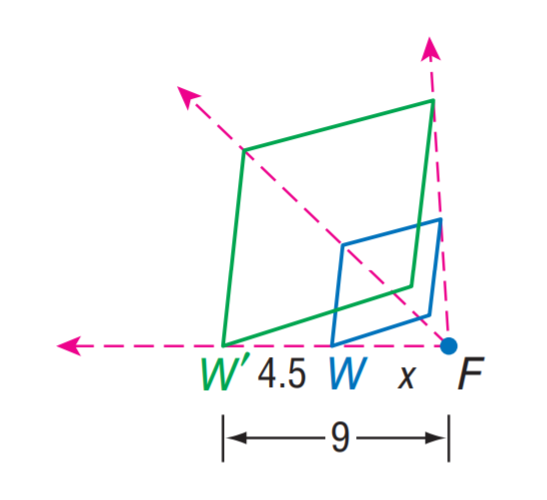Can you explain why the other options are incorrect for the scale factor from W to W'? Certainly! The scale factor is a proportional value that defines how much larger or smaller one object is compared to another. In this case, the length from W to W' is explicitly marked as 4.5, and from W' to F it is marked as 9. Hence, the scale factor is not B: 4.5, since that would mean W' was 4.5 times larger than W. Option C: 9, and option D: 18 are also incorrect because these would imply that W' should be even larger compared to W, which it is not according to the image provided. 